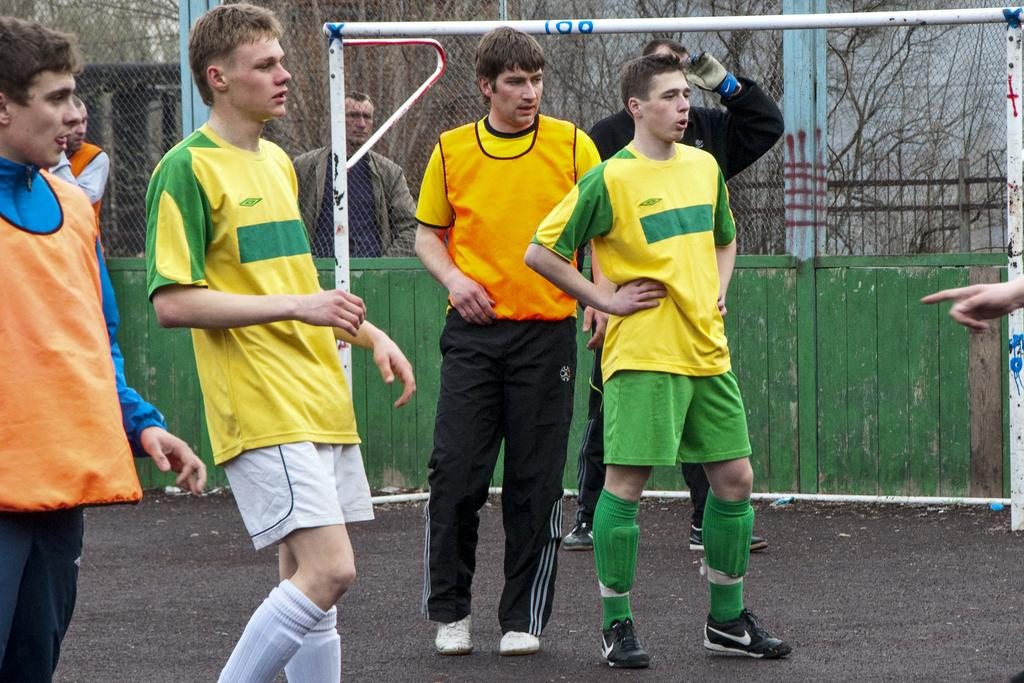What can be seen in the image regarding people? There are men standing in the image. Can you describe the clothing of one of the men? One man is wearing gloves on his hands, and another man is wearing a jacket. What type of natural environment is visible in the image? There are trees visible in the image. What type of barrier can be seen in the image? There is a metal fence in the image. What sports-related object is present in the image? There is a goal pole in the image. What type of beast can be seen interacting with the goal pole in the image? There is no beast present in the image; it only features men standing, trees, a metal fence, and a goal pole. What type of liquid is being used to lubricate the metal fence in the image? There is no liquid present in the image, and the metal fence does not require lubrication. 